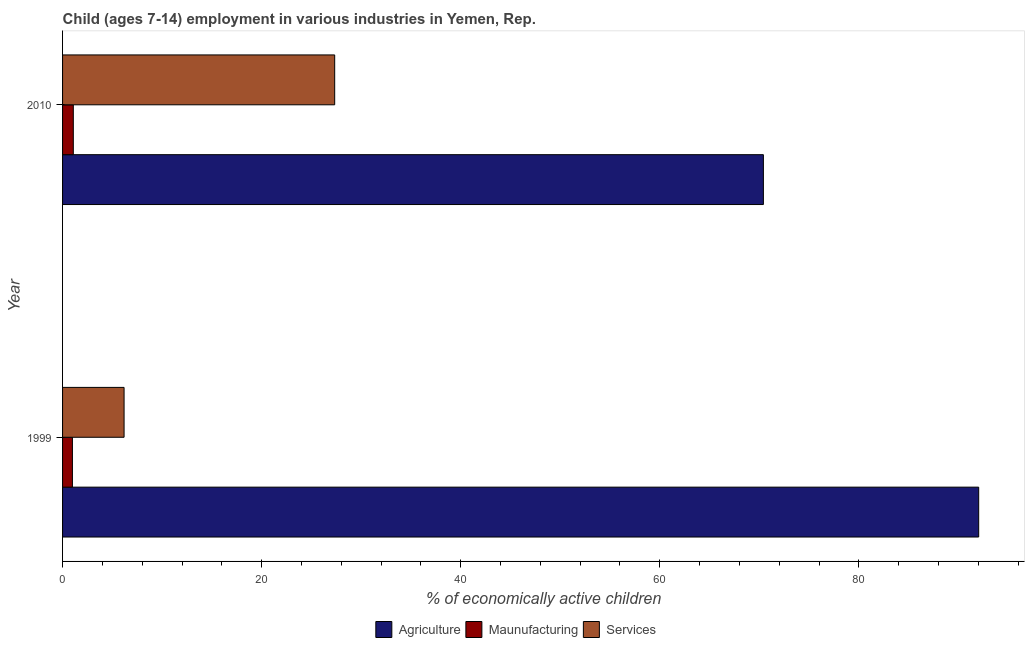How many groups of bars are there?
Make the answer very short. 2. Are the number of bars on each tick of the Y-axis equal?
Provide a short and direct response. Yes. How many bars are there on the 2nd tick from the bottom?
Provide a short and direct response. 3. What is the percentage of economically active children in agriculture in 1999?
Provide a succinct answer. 92.04. Across all years, what is the maximum percentage of economically active children in manufacturing?
Give a very brief answer. 1.08. Across all years, what is the minimum percentage of economically active children in manufacturing?
Provide a short and direct response. 0.99. In which year was the percentage of economically active children in agriculture minimum?
Make the answer very short. 2010. What is the total percentage of economically active children in manufacturing in the graph?
Your answer should be very brief. 2.07. What is the difference between the percentage of economically active children in manufacturing in 1999 and that in 2010?
Your response must be concise. -0.09. What is the difference between the percentage of economically active children in services in 2010 and the percentage of economically active children in manufacturing in 1999?
Your answer should be very brief. 26.35. What is the average percentage of economically active children in agriculture per year?
Give a very brief answer. 81.22. In the year 1999, what is the difference between the percentage of economically active children in agriculture and percentage of economically active children in services?
Ensure brevity in your answer.  85.86. What is the ratio of the percentage of economically active children in agriculture in 1999 to that in 2010?
Your answer should be very brief. 1.31. Is the percentage of economically active children in agriculture in 1999 less than that in 2010?
Give a very brief answer. No. In how many years, is the percentage of economically active children in agriculture greater than the average percentage of economically active children in agriculture taken over all years?
Give a very brief answer. 1. What does the 2nd bar from the top in 2010 represents?
Make the answer very short. Maunufacturing. What does the 1st bar from the bottom in 1999 represents?
Offer a very short reply. Agriculture. Is it the case that in every year, the sum of the percentage of economically active children in agriculture and percentage of economically active children in manufacturing is greater than the percentage of economically active children in services?
Your answer should be compact. Yes. How many bars are there?
Offer a very short reply. 6. Are all the bars in the graph horizontal?
Offer a terse response. Yes. What is the difference between two consecutive major ticks on the X-axis?
Offer a very short reply. 20. Are the values on the major ticks of X-axis written in scientific E-notation?
Your answer should be compact. No. How are the legend labels stacked?
Keep it short and to the point. Horizontal. What is the title of the graph?
Give a very brief answer. Child (ages 7-14) employment in various industries in Yemen, Rep. Does "Ages 0-14" appear as one of the legend labels in the graph?
Provide a succinct answer. No. What is the label or title of the X-axis?
Make the answer very short. % of economically active children. What is the label or title of the Y-axis?
Your answer should be compact. Year. What is the % of economically active children of Agriculture in 1999?
Give a very brief answer. 92.04. What is the % of economically active children in Services in 1999?
Your response must be concise. 6.18. What is the % of economically active children in Agriculture in 2010?
Give a very brief answer. 70.41. What is the % of economically active children in Maunufacturing in 2010?
Your response must be concise. 1.08. What is the % of economically active children in Services in 2010?
Keep it short and to the point. 27.34. Across all years, what is the maximum % of economically active children in Agriculture?
Keep it short and to the point. 92.04. Across all years, what is the maximum % of economically active children in Maunufacturing?
Your answer should be very brief. 1.08. Across all years, what is the maximum % of economically active children of Services?
Give a very brief answer. 27.34. Across all years, what is the minimum % of economically active children of Agriculture?
Ensure brevity in your answer.  70.41. Across all years, what is the minimum % of economically active children of Services?
Your answer should be very brief. 6.18. What is the total % of economically active children of Agriculture in the graph?
Offer a very short reply. 162.45. What is the total % of economically active children of Maunufacturing in the graph?
Make the answer very short. 2.07. What is the total % of economically active children of Services in the graph?
Keep it short and to the point. 33.52. What is the difference between the % of economically active children of Agriculture in 1999 and that in 2010?
Provide a succinct answer. 21.63. What is the difference between the % of economically active children of Maunufacturing in 1999 and that in 2010?
Give a very brief answer. -0.09. What is the difference between the % of economically active children of Services in 1999 and that in 2010?
Your answer should be compact. -21.16. What is the difference between the % of economically active children in Agriculture in 1999 and the % of economically active children in Maunufacturing in 2010?
Keep it short and to the point. 90.96. What is the difference between the % of economically active children in Agriculture in 1999 and the % of economically active children in Services in 2010?
Offer a very short reply. 64.7. What is the difference between the % of economically active children of Maunufacturing in 1999 and the % of economically active children of Services in 2010?
Make the answer very short. -26.35. What is the average % of economically active children of Agriculture per year?
Ensure brevity in your answer.  81.22. What is the average % of economically active children in Maunufacturing per year?
Provide a succinct answer. 1.03. What is the average % of economically active children in Services per year?
Keep it short and to the point. 16.76. In the year 1999, what is the difference between the % of economically active children in Agriculture and % of economically active children in Maunufacturing?
Make the answer very short. 91.05. In the year 1999, what is the difference between the % of economically active children of Agriculture and % of economically active children of Services?
Offer a very short reply. 85.86. In the year 1999, what is the difference between the % of economically active children in Maunufacturing and % of economically active children in Services?
Keep it short and to the point. -5.19. In the year 2010, what is the difference between the % of economically active children of Agriculture and % of economically active children of Maunufacturing?
Provide a succinct answer. 69.33. In the year 2010, what is the difference between the % of economically active children in Agriculture and % of economically active children in Services?
Your answer should be very brief. 43.07. In the year 2010, what is the difference between the % of economically active children of Maunufacturing and % of economically active children of Services?
Offer a very short reply. -26.26. What is the ratio of the % of economically active children of Agriculture in 1999 to that in 2010?
Offer a very short reply. 1.31. What is the ratio of the % of economically active children in Maunufacturing in 1999 to that in 2010?
Offer a terse response. 0.92. What is the ratio of the % of economically active children in Services in 1999 to that in 2010?
Keep it short and to the point. 0.23. What is the difference between the highest and the second highest % of economically active children of Agriculture?
Your answer should be very brief. 21.63. What is the difference between the highest and the second highest % of economically active children in Maunufacturing?
Your answer should be compact. 0.09. What is the difference between the highest and the second highest % of economically active children in Services?
Offer a terse response. 21.16. What is the difference between the highest and the lowest % of economically active children in Agriculture?
Give a very brief answer. 21.63. What is the difference between the highest and the lowest % of economically active children in Maunufacturing?
Make the answer very short. 0.09. What is the difference between the highest and the lowest % of economically active children of Services?
Provide a succinct answer. 21.16. 